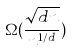<formula> <loc_0><loc_0><loc_500><loc_500>\Omega ( \frac { \sqrt { d n } } { n ^ { 1 / d } } )</formula> 